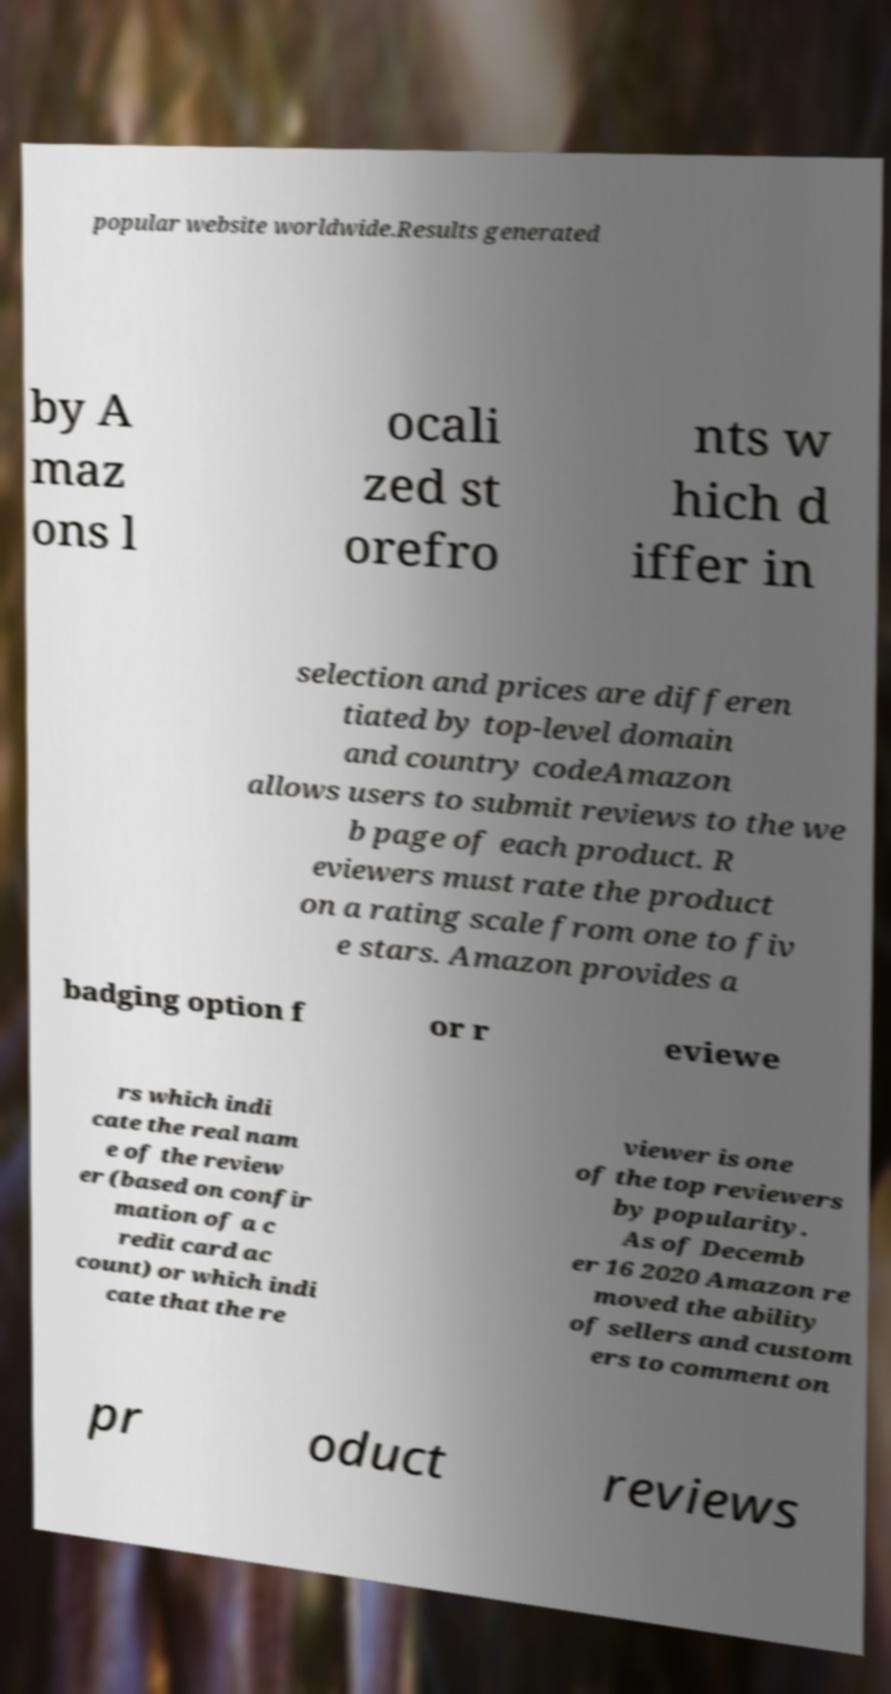Please read and relay the text visible in this image. What does it say? popular website worldwide.Results generated by A maz ons l ocali zed st orefro nts w hich d iffer in selection and prices are differen tiated by top-level domain and country codeAmazon allows users to submit reviews to the we b page of each product. R eviewers must rate the product on a rating scale from one to fiv e stars. Amazon provides a badging option f or r eviewe rs which indi cate the real nam e of the review er (based on confir mation of a c redit card ac count) or which indi cate that the re viewer is one of the top reviewers by popularity. As of Decemb er 16 2020 Amazon re moved the ability of sellers and custom ers to comment on pr oduct reviews 